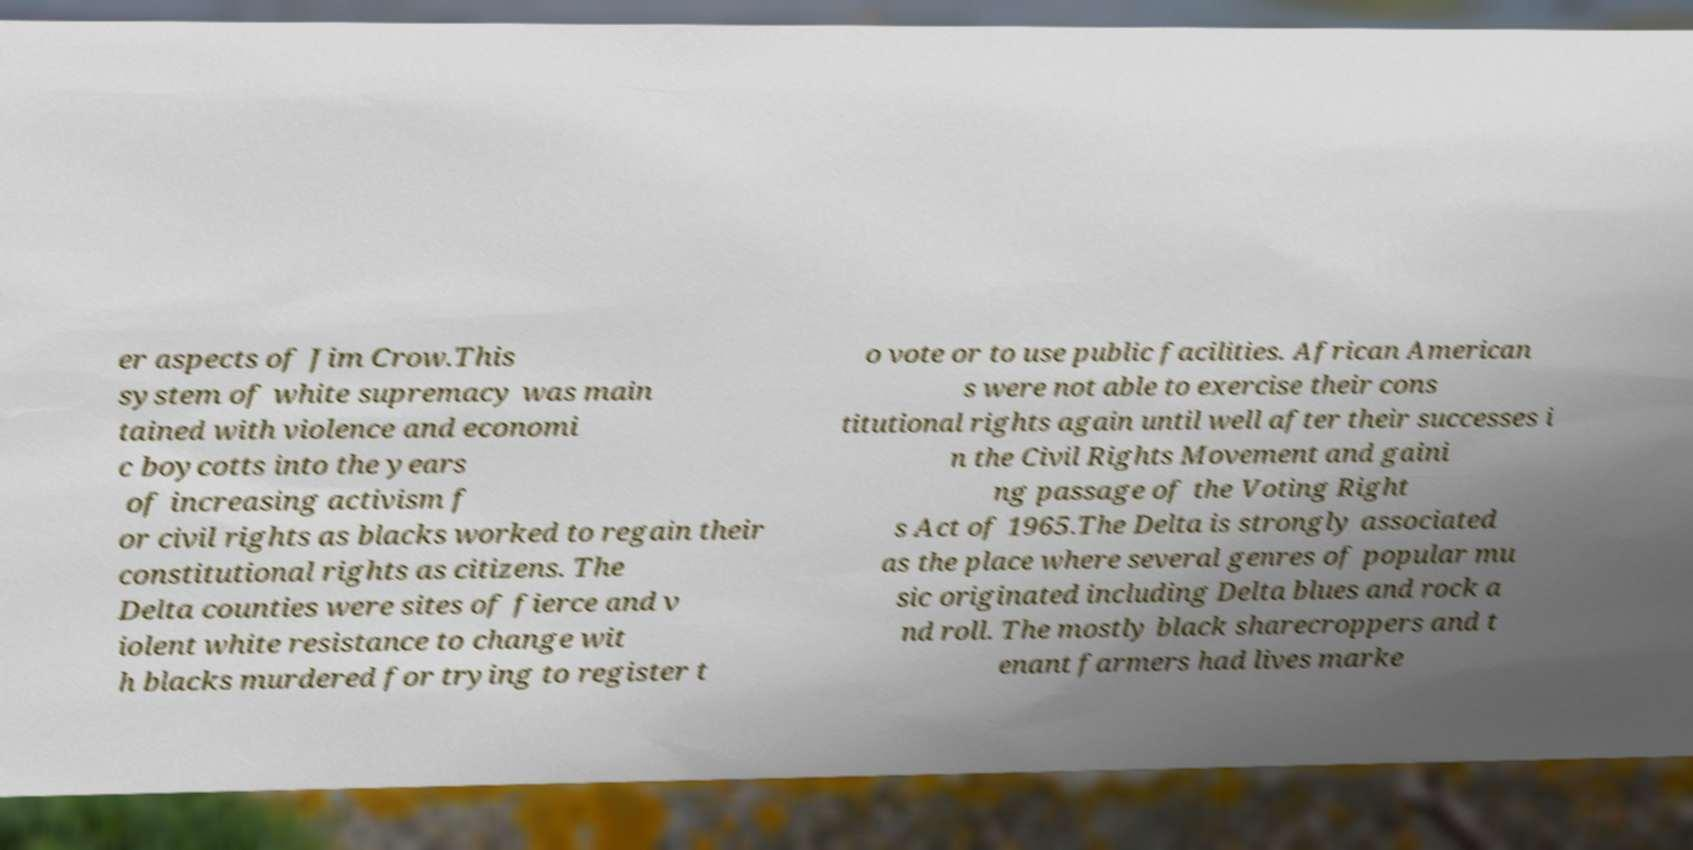Could you assist in decoding the text presented in this image and type it out clearly? er aspects of Jim Crow.This system of white supremacy was main tained with violence and economi c boycotts into the years of increasing activism f or civil rights as blacks worked to regain their constitutional rights as citizens. The Delta counties were sites of fierce and v iolent white resistance to change wit h blacks murdered for trying to register t o vote or to use public facilities. African American s were not able to exercise their cons titutional rights again until well after their successes i n the Civil Rights Movement and gaini ng passage of the Voting Right s Act of 1965.The Delta is strongly associated as the place where several genres of popular mu sic originated including Delta blues and rock a nd roll. The mostly black sharecroppers and t enant farmers had lives marke 